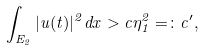<formula> <loc_0><loc_0><loc_500><loc_500>\int _ { E _ { 2 } } | u ( t ) | ^ { 2 } d x > c \eta _ { 1 } ^ { 2 } = \colon c ^ { \prime } ,</formula> 